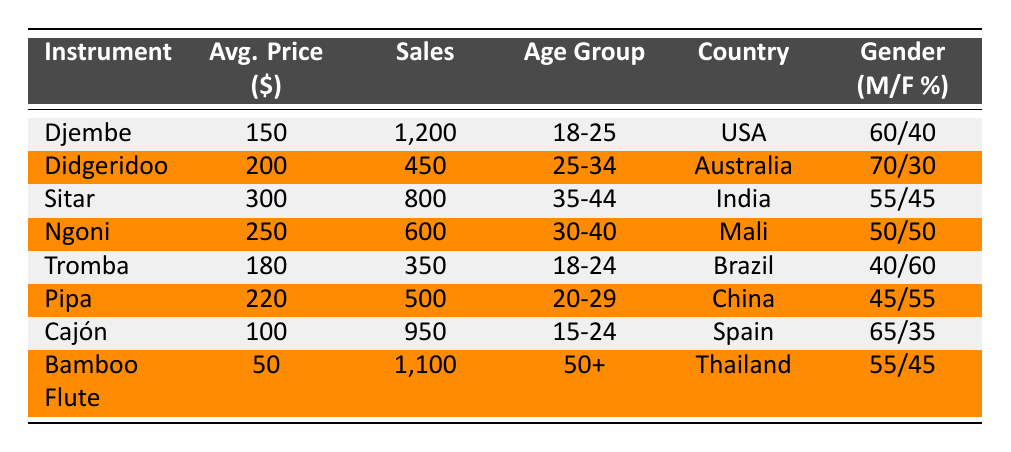What is the average price of the Djembe? The table indicates that the average price of the Djembe is listed under the "Avg. Price ($)" column next to the Djembe row. It shows the value of 150.
Answer: 150 How many sales did the Bamboo Flute make last year? To find the sales of the Bamboo Flute, look at the "Sales" column corresponding to the Bamboo Flute in the table, which states 1100.
Answer: 1100 Which instrument had the highest average price? By looking at the "Avg. Price ($)" column, the Sitar has the highest value of 300.
Answer: Sitar Is the gender distribution for the Didgeridoo mostly male? Checking the "Gender (M/F %)" for the Didgeridoo shows 70% male and 30% female, indicating that it is indeed mostly male.
Answer: Yes What is the total sales of instruments sold to the age group 18-25? The instruments for this age group are the Djembe (1200) and Tromba (350). Summing these gives 1200 + 350 = 1550.
Answer: 1550 Which country has the lowest average price for its traditional instrument? Looking at the "Avg. Price ($)" column, the Bamboo Flute (50) has the lowest average price compared to other instruments.
Answer: Thailand What percentage of sales for the Cajón were made by males? The Cajón has a gender distribution of 65% male, meaning the majority of sales were made by males.
Answer: Yes How many more sales did the Djembe have compared to the Ngoni? The Djembe sold 1200 and the Ngoni sold 600. The difference is 1200 - 600 = 600.
Answer: 600 Which instrument has a higher average price, Pipa or Tromba? The Pipa has an average price of 220 while the Tromba is 180. Comparing the two, 220 > 180 indicates that the Pipa is higher.
Answer: Pipa 